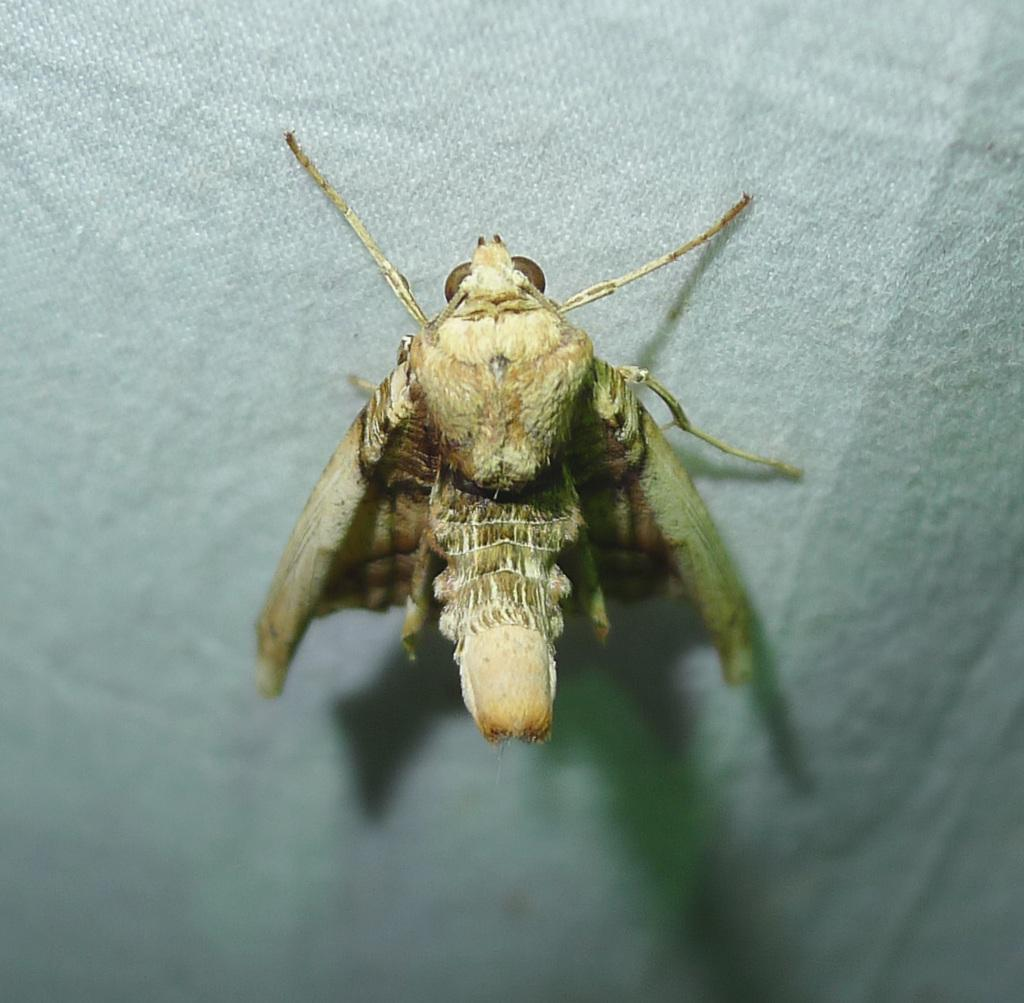What type of creature can be seen in the image? There is an insect in the image. What color is the insect? The insect is brown in color. What is the background of the image? The background of the image is white. What type of drink is the insect holding in the image? There is no drink present in the image, and the insect is not holding anything. 